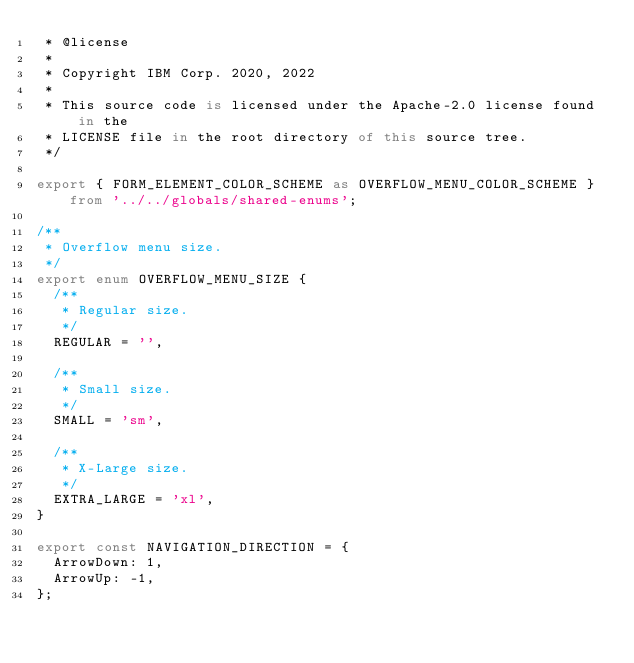<code> <loc_0><loc_0><loc_500><loc_500><_TypeScript_> * @license
 *
 * Copyright IBM Corp. 2020, 2022
 *
 * This source code is licensed under the Apache-2.0 license found in the
 * LICENSE file in the root directory of this source tree.
 */

export { FORM_ELEMENT_COLOR_SCHEME as OVERFLOW_MENU_COLOR_SCHEME } from '../../globals/shared-enums';

/**
 * Overflow menu size.
 */
export enum OVERFLOW_MENU_SIZE {
  /**
   * Regular size.
   */
  REGULAR = '',

  /**
   * Small size.
   */
  SMALL = 'sm',

  /**
   * X-Large size.
   */
  EXTRA_LARGE = 'xl',
}

export const NAVIGATION_DIRECTION = {
  ArrowDown: 1,
  ArrowUp: -1,
};
</code> 